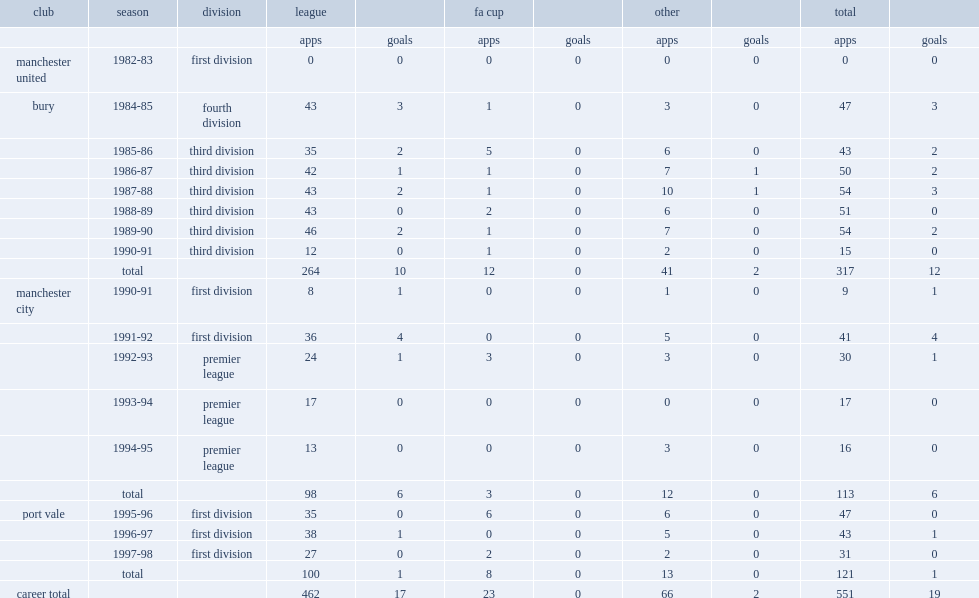How many goals did hill play for bury totally? 12.0. 